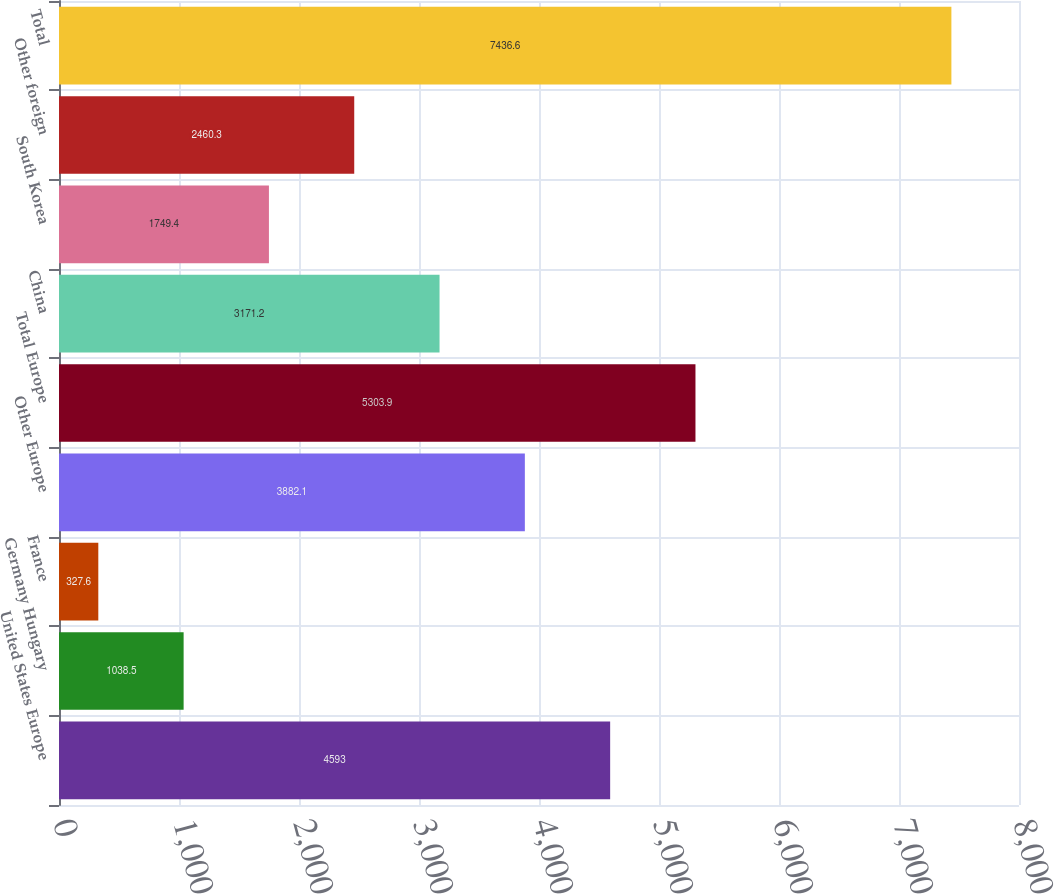Convert chart to OTSL. <chart><loc_0><loc_0><loc_500><loc_500><bar_chart><fcel>United States Europe<fcel>Germany Hungary<fcel>France<fcel>Other Europe<fcel>Total Europe<fcel>China<fcel>South Korea<fcel>Other foreign<fcel>Total<nl><fcel>4593<fcel>1038.5<fcel>327.6<fcel>3882.1<fcel>5303.9<fcel>3171.2<fcel>1749.4<fcel>2460.3<fcel>7436.6<nl></chart> 